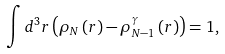<formula> <loc_0><loc_0><loc_500><loc_500>\int d ^ { 3 } r \left ( \rho _ { N } \left ( r \right ) - \rho _ { N - 1 } ^ { \gamma } \left ( r \right ) \right ) = 1 ,</formula> 